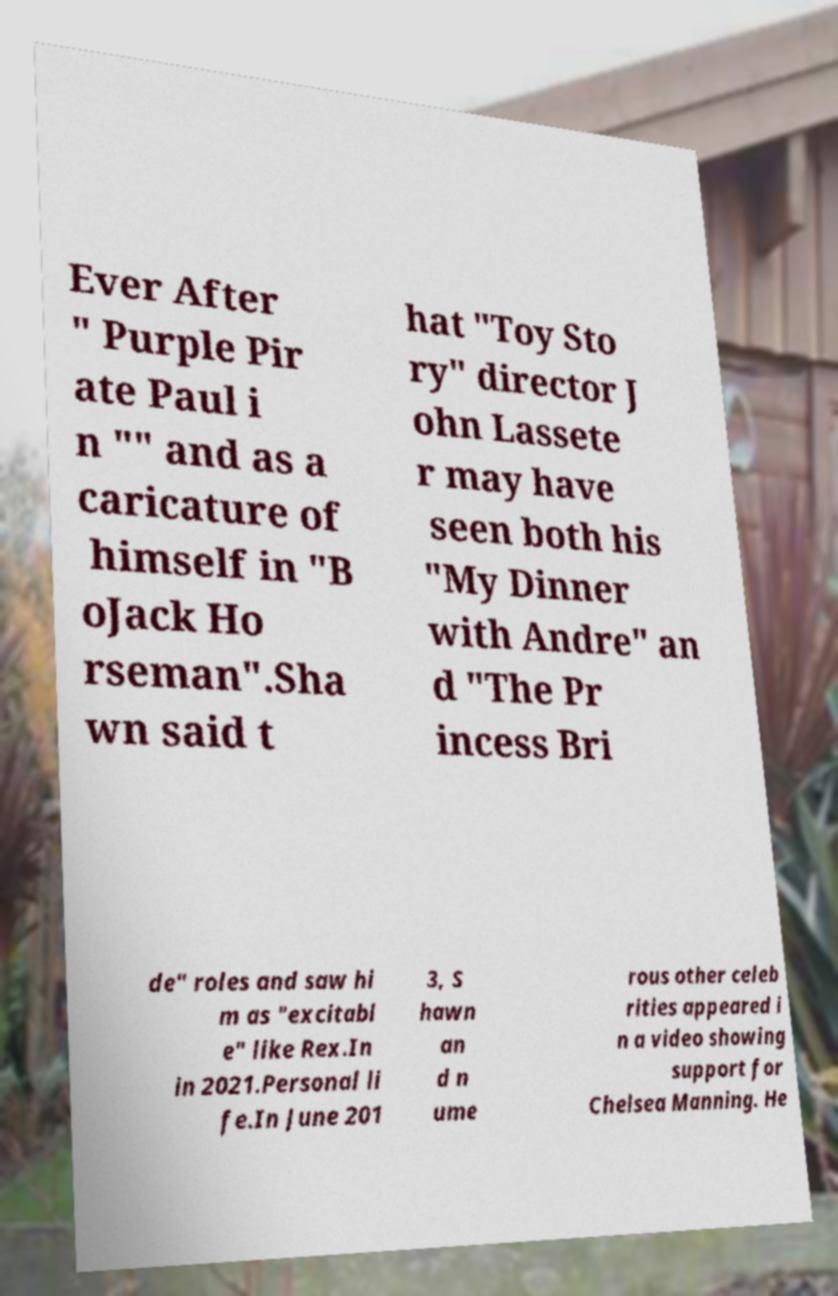I need the written content from this picture converted into text. Can you do that? Ever After " Purple Pir ate Paul i n "" and as a caricature of himself in "B oJack Ho rseman".Sha wn said t hat "Toy Sto ry" director J ohn Lassete r may have seen both his "My Dinner with Andre" an d "The Pr incess Bri de" roles and saw hi m as "excitabl e" like Rex.In in 2021.Personal li fe.In June 201 3, S hawn an d n ume rous other celeb rities appeared i n a video showing support for Chelsea Manning. He 